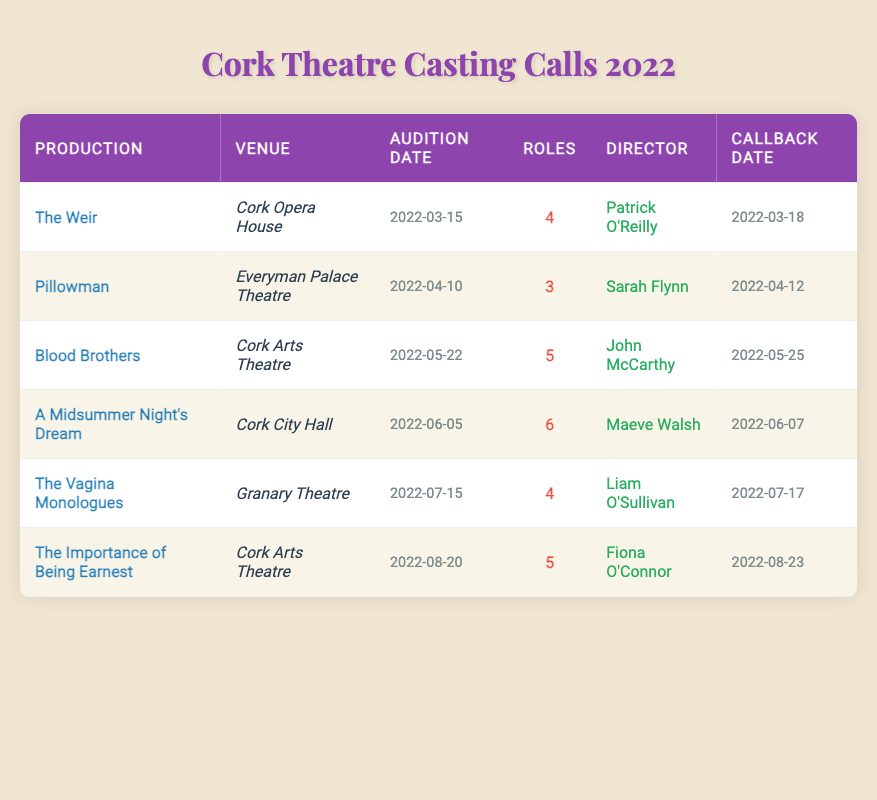What is the audition date for "Blood Brothers"? The audition date for "Blood Brothers" is listed in the corresponding row of the table under the "Audition Date" column. According to the table, it is on 2022-05-22.
Answer: 2022-05-22 How many roles are available in "A Midsummer Night's Dream"? The number of available roles for "A Midsummer Night's Dream" can be found in the respective row in the table under the "Roles" column. It shows there are 6 roles available.
Answer: 6 Which production is directed by Sarah Flynn? To find the production directed by Sarah Flynn, I look through the "Director" column in the table. The corresponding production name is listed next to her name, which is "Pillowman."
Answer: Pillowman How many total roles are available across all productions listed? To find the total number of roles, I sum the values in the "Roles" column from each row of the table: 4 + 3 + 5 + 6 + 4 + 5 = 27. Hence, the total number of roles available is 27.
Answer: 27 Is "The Vagina Monologues" audition date before "The Importance of Being Earnest"? I compare the audition dates of both productions by checking the "Audition Date" column. "The Vagina Monologues" has an audition date of 2022-07-15, and "The Importance of Being Earnest" has an audition date of 2022-08-20. Since 2022-07-15 is before 2022-08-20, the statement is true.
Answer: Yes Which director has the most roles available in their production based on the table? First, I review the "Roles" column to identify the number of roles associated with each director. "A Midsummer Night's Dream," directed by Maeve Walsh, has 6 roles available, which is the highest among all directors listed.
Answer: Maeve Walsh What is the callback date for "The Weir"? I find the callback date in the table by looking at the row for "The Weir." The "Callback Date" column indicates that the callback date is 2022-03-18.
Answer: 2022-03-18 Are there more productions at the Cork Arts Theatre than any other venue? I review the "Theater Venue" column to count the number of productions at Cork Arts Theatre. There are two productions, "Blood Brothers" and "The Importance of Being Earnest." Then, I compare this with other venues: Cork Opera House (1), Everyman Palace Theatre (1), Cork City Hall (1), and Granary Theatre (1). Cork Arts Theatre has the highest at 2.
Answer: Yes What is the average number of roles available per production? To find the average, I first sum the roles: 4 + 3 + 5 + 6 + 4 + 5 = 27. Next, I divide this total by the number of productions, which is 6. Thus, the average is 27/6 = 4.5.
Answer: 4.5 